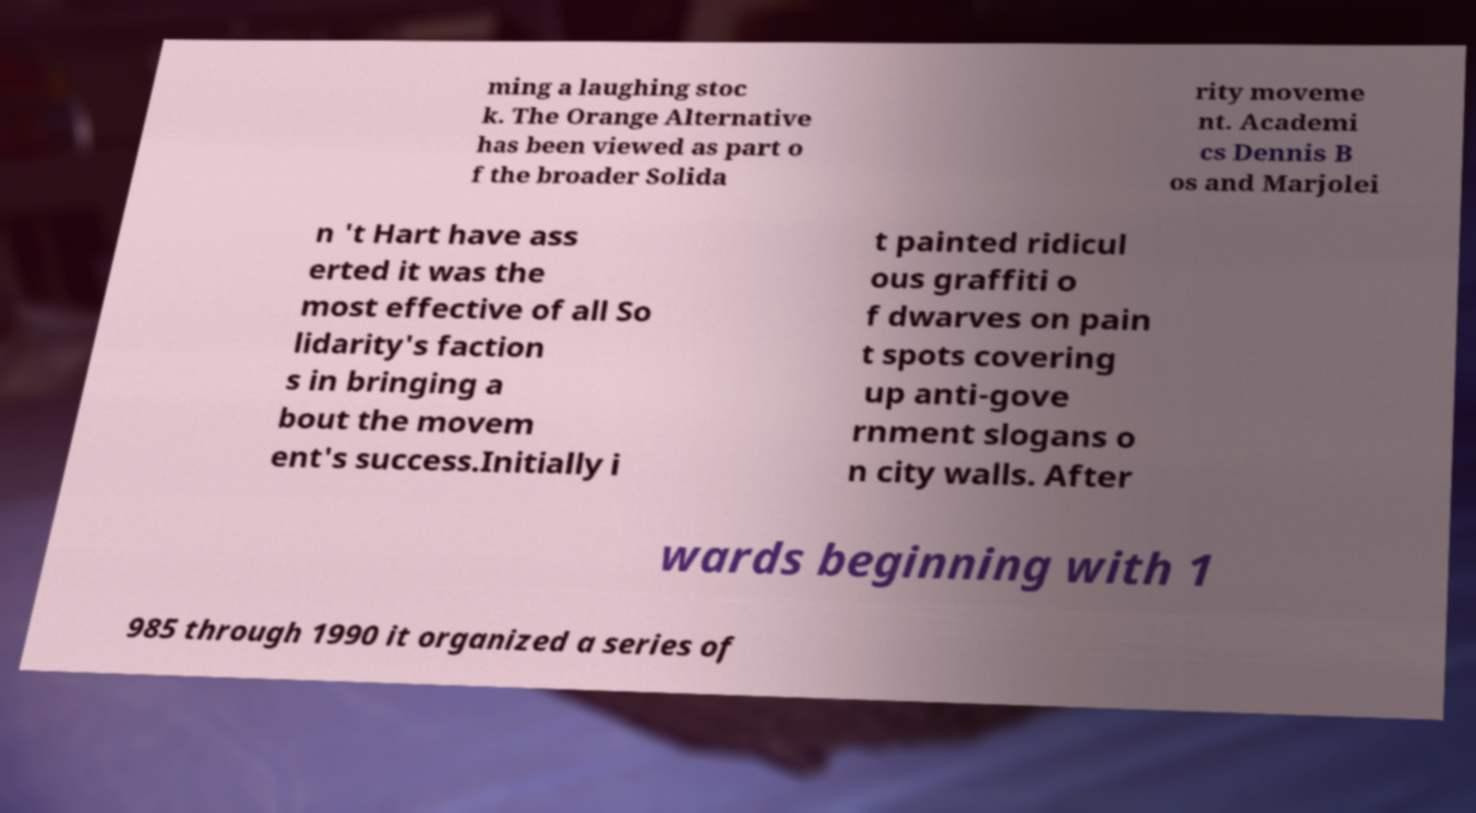Please read and relay the text visible in this image. What does it say? ming a laughing stoc k. The Orange Alternative has been viewed as part o f the broader Solida rity moveme nt. Academi cs Dennis B os and Marjolei n 't Hart have ass erted it was the most effective of all So lidarity's faction s in bringing a bout the movem ent's success.Initially i t painted ridicul ous graffiti o f dwarves on pain t spots covering up anti-gove rnment slogans o n city walls. After wards beginning with 1 985 through 1990 it organized a series of 